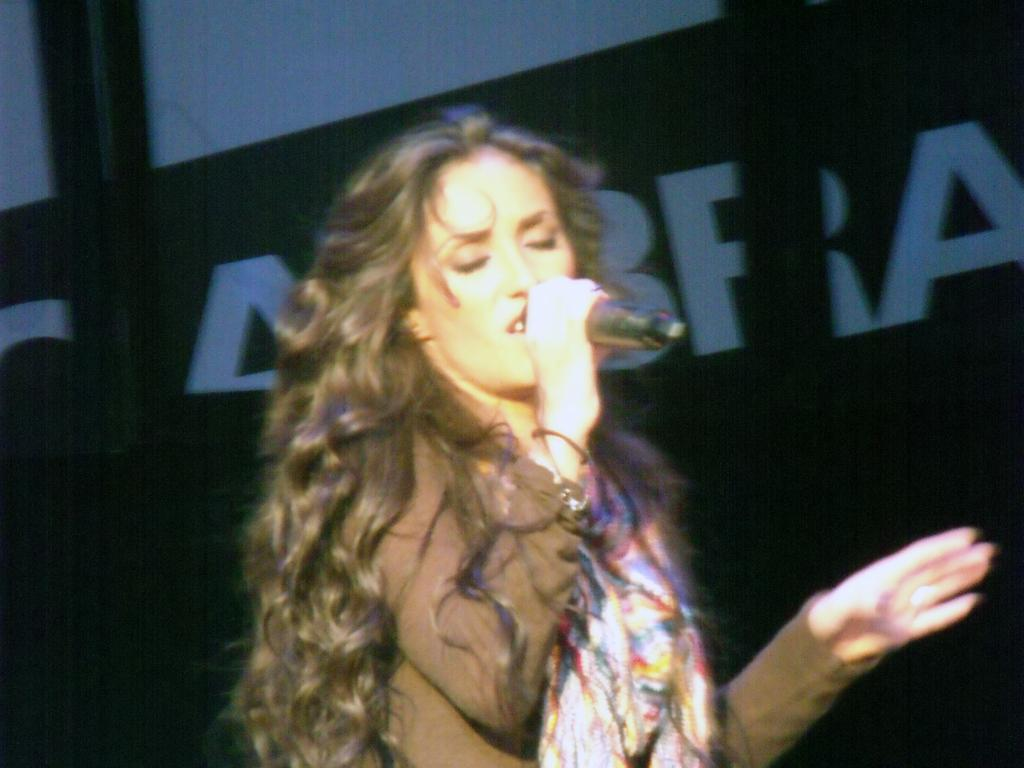Who is the main subject in the image? There is a woman in the image. What is the woman holding in the image? The woman is holding a microphone. What can be seen in the background of the image? There is a banner in the background of the image. What is written on the banner? The banner has letters on it. How far away is the band from the woman in the image? There is no band present in the image, so it is not possible to determine the distance between the woman and a band. 